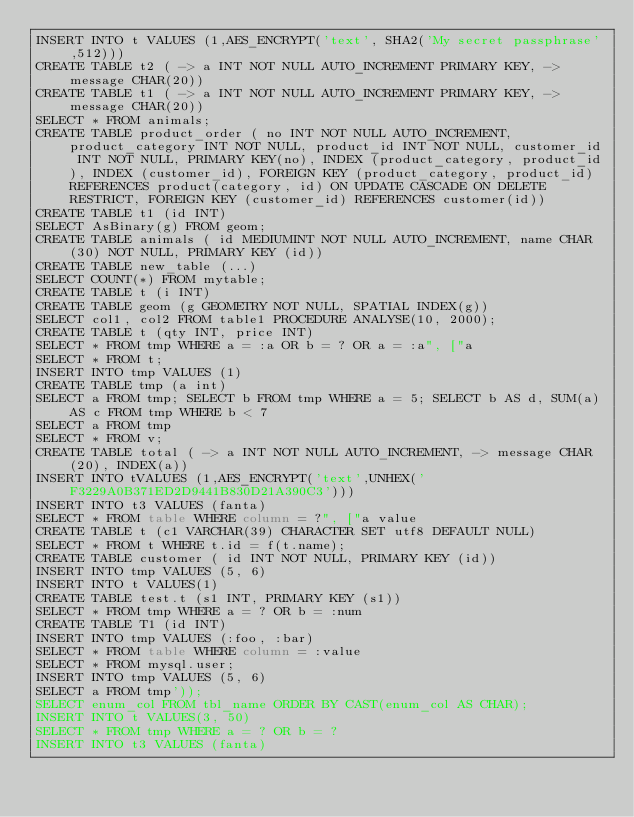<code> <loc_0><loc_0><loc_500><loc_500><_SQL_>INSERT INTO t VALUES (1,AES_ENCRYPT('text', SHA2('My secret passphrase',512)))
CREATE TABLE t2 ( -> a INT NOT NULL AUTO_INCREMENT PRIMARY KEY, -> message CHAR(20))
CREATE TABLE t1 ( -> a INT NOT NULL AUTO_INCREMENT PRIMARY KEY, -> message CHAR(20))
SELECT * FROM animals;
CREATE TABLE product_order ( no INT NOT NULL AUTO_INCREMENT, product_category INT NOT NULL, product_id INT NOT NULL, customer_id INT NOT NULL, PRIMARY KEY(no), INDEX (product_category, product_id), INDEX (customer_id), FOREIGN KEY (product_category, product_id) REFERENCES product(category, id) ON UPDATE CASCADE ON DELETE RESTRICT, FOREIGN KEY (customer_id) REFERENCES customer(id))
CREATE TABLE t1 (id INT)
SELECT AsBinary(g) FROM geom;
CREATE TABLE animals ( id MEDIUMINT NOT NULL AUTO_INCREMENT, name CHAR(30) NOT NULL, PRIMARY KEY (id))
CREATE TABLE new_table (...)
SELECT COUNT(*) FROM mytable;
CREATE TABLE t (i INT)
CREATE TABLE geom (g GEOMETRY NOT NULL, SPATIAL INDEX(g))
SELECT col1, col2 FROM table1 PROCEDURE ANALYSE(10, 2000);
CREATE TABLE t (qty INT, price INT)
SELECT * FROM tmp WHERE a = :a OR b = ? OR a = :a", ["a
SELECT * FROM t;
INSERT INTO tmp VALUES (1)
CREATE TABLE tmp (a int)
SELECT a FROM tmp; SELECT b FROM tmp WHERE a = 5; SELECT b AS d, SUM(a) AS c FROM tmp WHERE b < 7
SELECT a FROM tmp
SELECT * FROM v;
CREATE TABLE total ( -> a INT NOT NULL AUTO_INCREMENT, -> message CHAR(20), INDEX(a))
INSERT INTO tVALUES (1,AES_ENCRYPT('text',UNHEX('F3229A0B371ED2D9441B830D21A390C3')))
INSERT INTO t3 VALUES (fanta)
SELECT * FROM table WHERE column = ?", ["a value
CREATE TABLE t (c1 VARCHAR(39) CHARACTER SET utf8 DEFAULT NULL)
SELECT * FROM t WHERE t.id = f(t.name);
CREATE TABLE customer ( id INT NOT NULL, PRIMARY KEY (id))
INSERT INTO tmp VALUES (5, 6)
INSERT INTO t VALUES(1)
CREATE TABLE test.t (s1 INT, PRIMARY KEY (s1))
SELECT * FROM tmp WHERE a = ? OR b = :num
CREATE TABLE T1 (id INT)
INSERT INTO tmp VALUES (:foo, :bar)
SELECT * FROM table WHERE column = :value
SELECT * FROM mysql.user;
INSERT INTO tmp VALUES (5, 6)
SELECT a FROM tmp'));
SELECT enum_col FROM tbl_name ORDER BY CAST(enum_col AS CHAR);
INSERT INTO t VALUES(3, 50)
SELECT * FROM tmp WHERE a = ? OR b = ?
INSERT INTO t3 VALUES (fanta)
</code> 